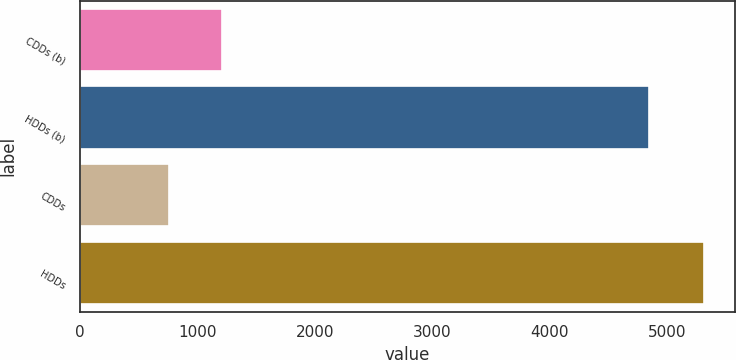Convert chart. <chart><loc_0><loc_0><loc_500><loc_500><bar_chart><fcel>CDDs (b)<fcel>HDDs (b)<fcel>CDDs<fcel>HDDs<nl><fcel>1210.3<fcel>4852<fcel>754<fcel>5317<nl></chart> 